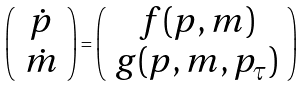<formula> <loc_0><loc_0><loc_500><loc_500>\left ( \begin{array} { c } \dot { p } \\ \dot { m } \end{array} \right ) = \left ( \begin{array} { c } f ( p , m ) \\ g ( p , m , p _ { \tau } ) \end{array} \right )</formula> 